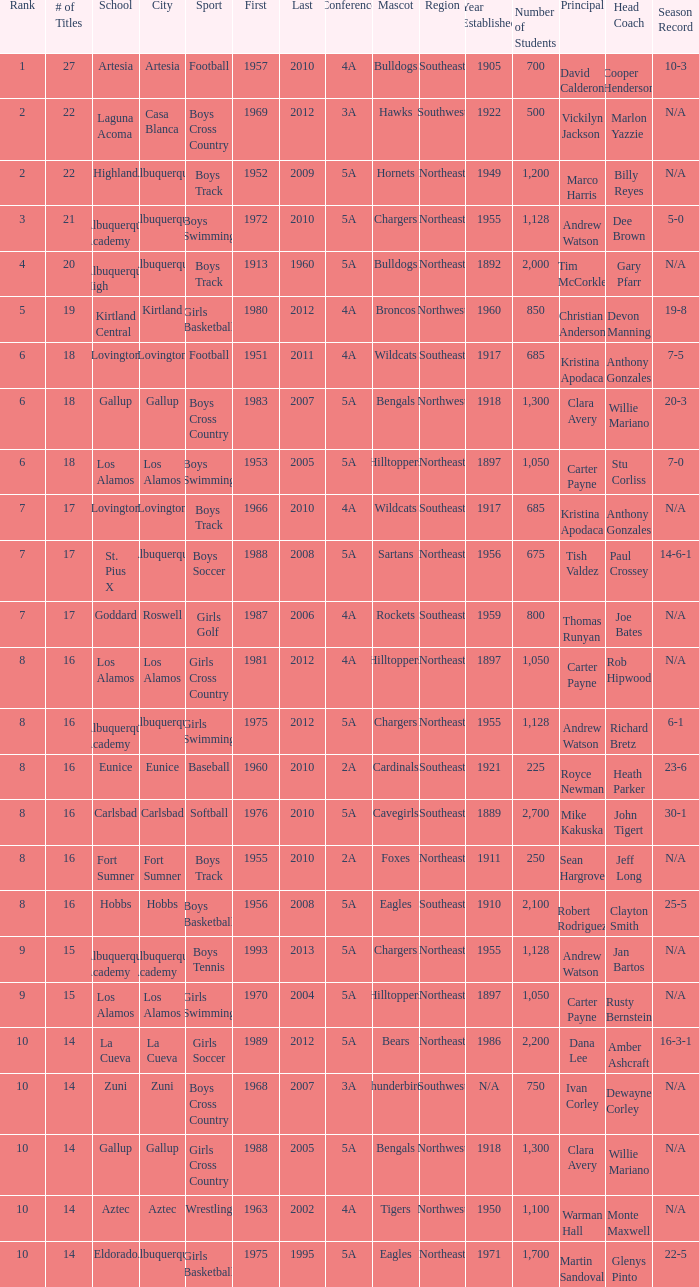What is the total rank number for Los Alamos' girls cross country? 1.0. 